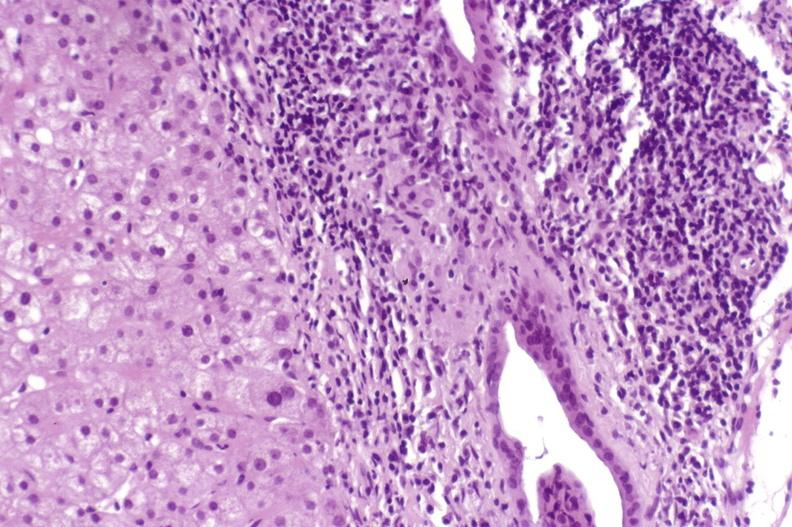what does this image show?
Answer the question using a single word or phrase. Primary biliary cirrhosis 